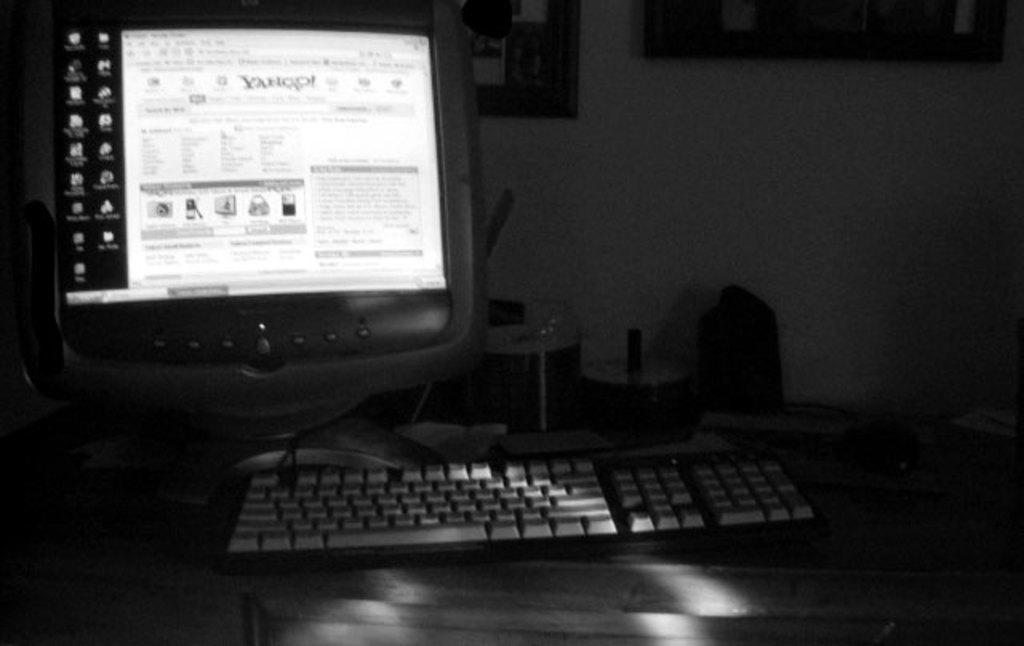<image>
Render a clear and concise summary of the photo. A keyboard is on a table and the monitor is open to Yahoo. 